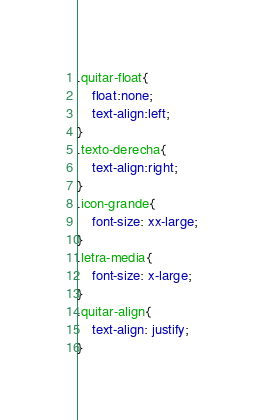Convert code to text. <code><loc_0><loc_0><loc_500><loc_500><_CSS_>.quitar-float{
	float:none;
	text-align:left;
}
.texto-derecha{
	text-align:right;
}
.icon-grande{
	font-size: xx-large;
}
.letra-media{
	font-size: x-large;
}
.quitar-align{
	text-align: justify;
}</code> 